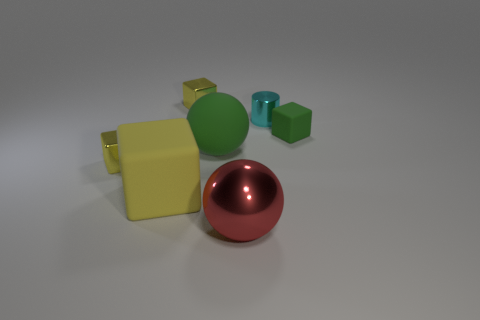Subtract all green cubes. How many cubes are left? 3 Add 1 small metal objects. How many objects exist? 8 Subtract all cyan cylinders. How many yellow cubes are left? 3 Subtract 2 cubes. How many cubes are left? 2 Subtract all red balls. How many balls are left? 1 Subtract 0 blue spheres. How many objects are left? 7 Subtract all cubes. How many objects are left? 3 Subtract all purple balls. Subtract all red cylinders. How many balls are left? 2 Subtract all cyan things. Subtract all large rubber balls. How many objects are left? 5 Add 2 big green matte objects. How many big green matte objects are left? 3 